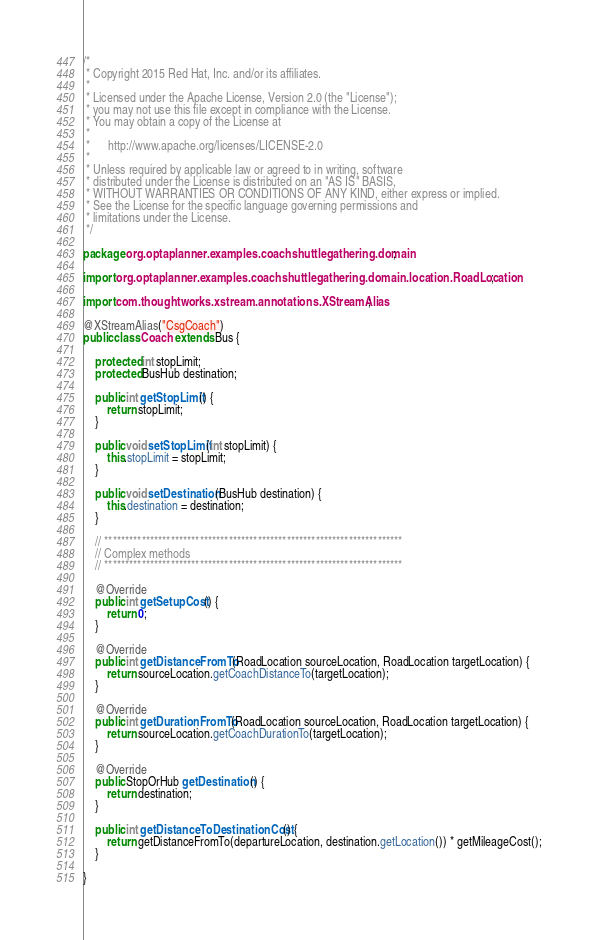Convert code to text. <code><loc_0><loc_0><loc_500><loc_500><_Java_>/*
 * Copyright 2015 Red Hat, Inc. and/or its affiliates.
 *
 * Licensed under the Apache License, Version 2.0 (the "License");
 * you may not use this file except in compliance with the License.
 * You may obtain a copy of the License at
 *
 *      http://www.apache.org/licenses/LICENSE-2.0
 *
 * Unless required by applicable law or agreed to in writing, software
 * distributed under the License is distributed on an "AS IS" BASIS,
 * WITHOUT WARRANTIES OR CONDITIONS OF ANY KIND, either express or implied.
 * See the License for the specific language governing permissions and
 * limitations under the License.
 */

package org.optaplanner.examples.coachshuttlegathering.domain;

import org.optaplanner.examples.coachshuttlegathering.domain.location.RoadLocation;

import com.thoughtworks.xstream.annotations.XStreamAlias;

@XStreamAlias("CsgCoach")
public class Coach extends Bus {

    protected int stopLimit;
    protected BusHub destination;

    public int getStopLimit() {
        return stopLimit;
    }

    public void setStopLimit(int stopLimit) {
        this.stopLimit = stopLimit;
    }

    public void setDestination(BusHub destination) {
        this.destination = destination;
    }

    // ************************************************************************
    // Complex methods
    // ************************************************************************

    @Override
    public int getSetupCost() {
        return 0;
    }

    @Override
    public int getDistanceFromTo(RoadLocation sourceLocation, RoadLocation targetLocation) {
        return sourceLocation.getCoachDistanceTo(targetLocation);
    }

    @Override
    public int getDurationFromTo(RoadLocation sourceLocation, RoadLocation targetLocation) {
        return sourceLocation.getCoachDurationTo(targetLocation);
    }

    @Override
    public StopOrHub getDestination() {
        return destination;
    }

    public int getDistanceToDestinationCost() {
        return getDistanceFromTo(departureLocation, destination.getLocation()) * getMileageCost();
    }

}
</code> 